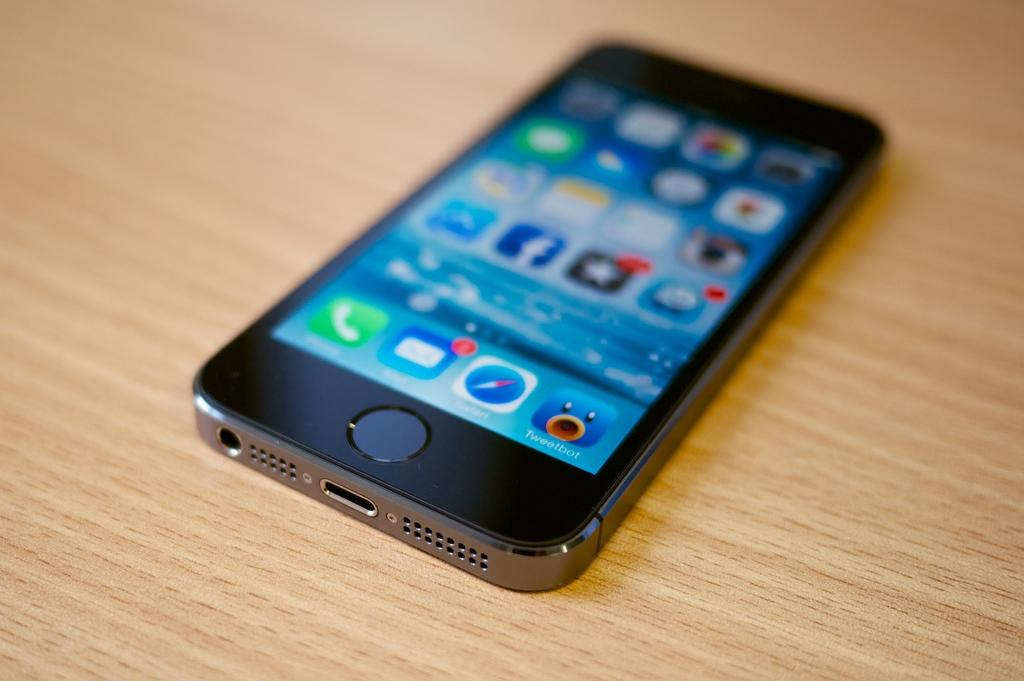<image>
Relay a brief, clear account of the picture shown. A cellphone on a wooden background with a Tweetbot app installed on it. 